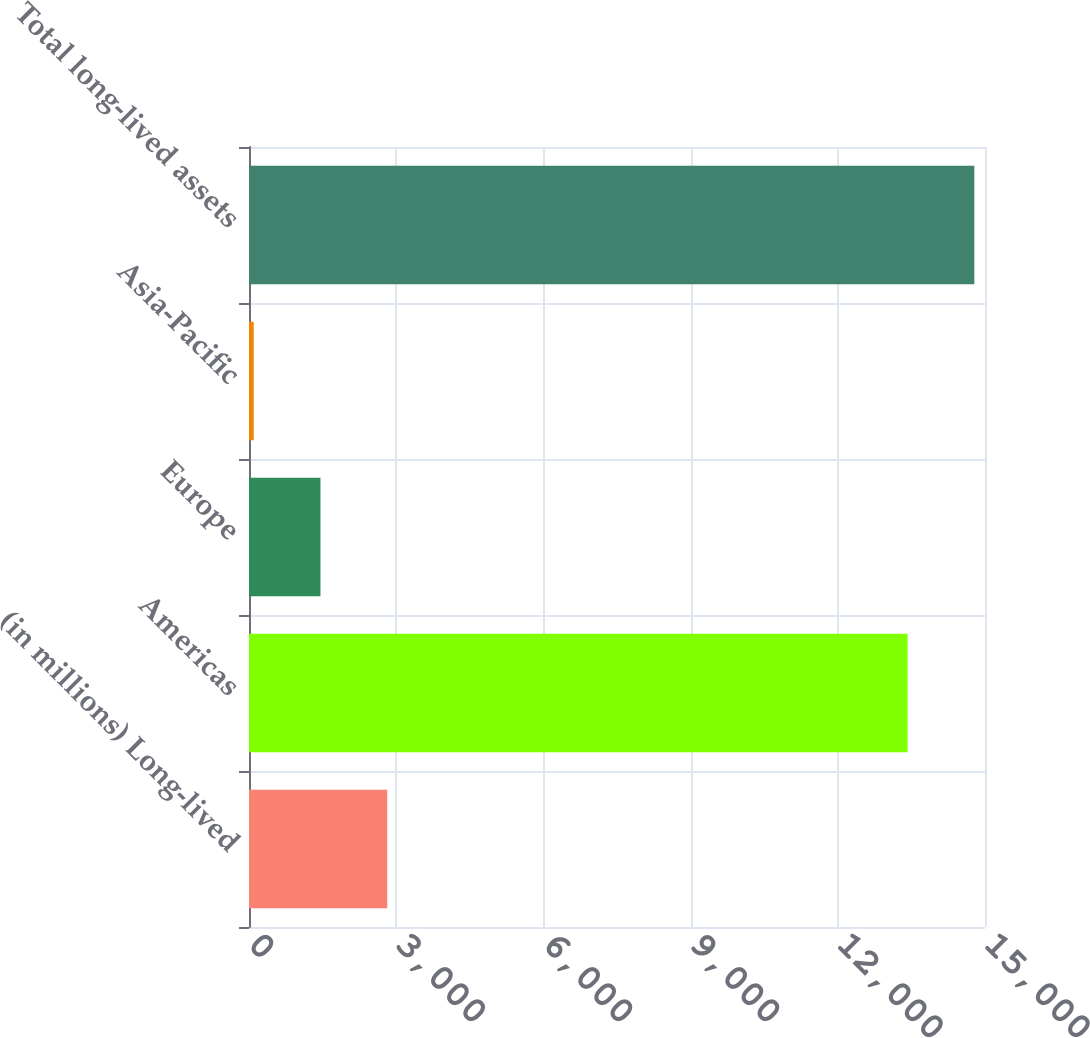Convert chart. <chart><loc_0><loc_0><loc_500><loc_500><bar_chart><fcel>(in millions) Long-lived<fcel>Americas<fcel>Europe<fcel>Asia-Pacific<fcel>Total long-lived assets<nl><fcel>2817.6<fcel>13422<fcel>1456.8<fcel>96<fcel>14782.8<nl></chart> 